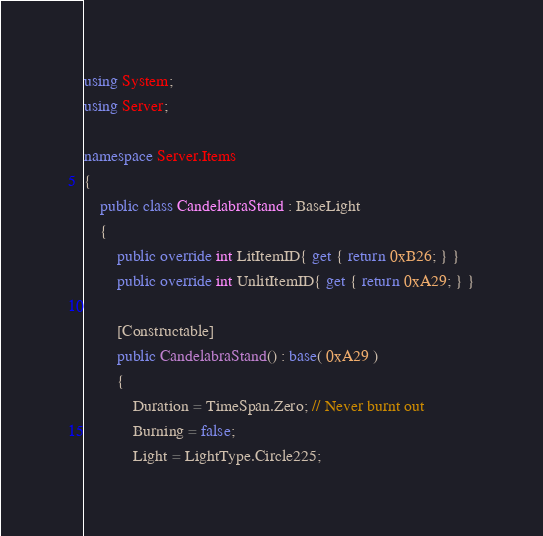<code> <loc_0><loc_0><loc_500><loc_500><_C#_>using System;
using Server;

namespace Server.Items
{
	public class CandelabraStand : BaseLight
	{
		public override int LitItemID{ get { return 0xB26; } }
		public override int UnlitItemID{ get { return 0xA29; } }

		[Constructable]
		public CandelabraStand() : base( 0xA29 )
		{
			Duration = TimeSpan.Zero; // Never burnt out
			Burning = false;
			Light = LightType.Circle225;</code> 